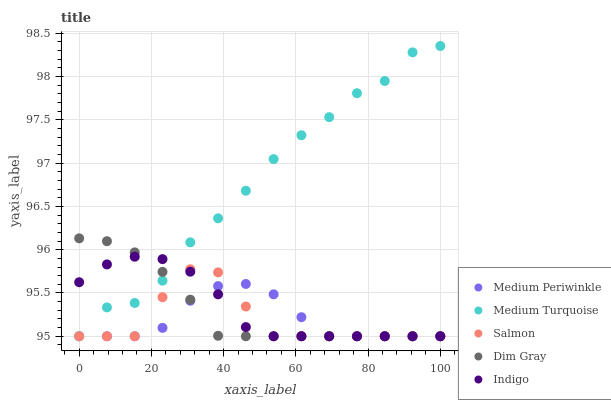Does Salmon have the minimum area under the curve?
Answer yes or no. Yes. Does Medium Turquoise have the maximum area under the curve?
Answer yes or no. Yes. Does Dim Gray have the minimum area under the curve?
Answer yes or no. No. Does Dim Gray have the maximum area under the curve?
Answer yes or no. No. Is Dim Gray the smoothest?
Answer yes or no. Yes. Is Medium Turquoise the roughest?
Answer yes or no. Yes. Is Medium Periwinkle the smoothest?
Answer yes or no. No. Is Medium Periwinkle the roughest?
Answer yes or no. No. Does Salmon have the lowest value?
Answer yes or no. Yes. Does Medium Turquoise have the highest value?
Answer yes or no. Yes. Does Dim Gray have the highest value?
Answer yes or no. No. Does Medium Turquoise intersect Salmon?
Answer yes or no. Yes. Is Medium Turquoise less than Salmon?
Answer yes or no. No. Is Medium Turquoise greater than Salmon?
Answer yes or no. No. 